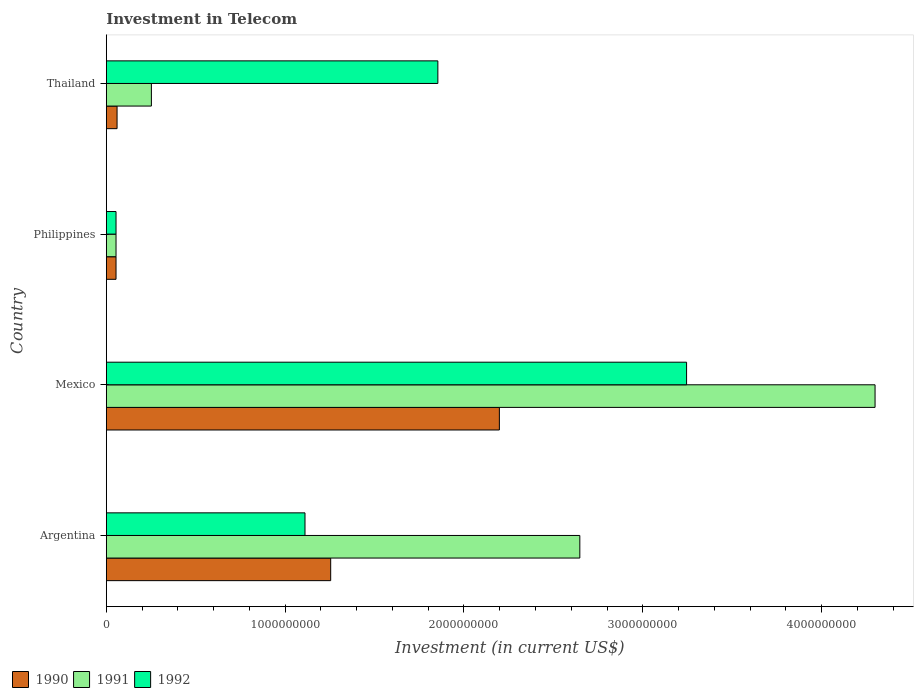How many different coloured bars are there?
Give a very brief answer. 3. How many bars are there on the 3rd tick from the top?
Give a very brief answer. 3. How many bars are there on the 3rd tick from the bottom?
Provide a short and direct response. 3. What is the label of the 1st group of bars from the top?
Your answer should be compact. Thailand. In how many cases, is the number of bars for a given country not equal to the number of legend labels?
Your answer should be very brief. 0. What is the amount invested in telecom in 1990 in Argentina?
Ensure brevity in your answer.  1.25e+09. Across all countries, what is the maximum amount invested in telecom in 1991?
Make the answer very short. 4.30e+09. Across all countries, what is the minimum amount invested in telecom in 1991?
Keep it short and to the point. 5.42e+07. What is the total amount invested in telecom in 1991 in the graph?
Your response must be concise. 7.25e+09. What is the difference between the amount invested in telecom in 1990 in Philippines and that in Thailand?
Provide a succinct answer. -5.80e+06. What is the difference between the amount invested in telecom in 1992 in Argentina and the amount invested in telecom in 1991 in Philippines?
Ensure brevity in your answer.  1.06e+09. What is the average amount invested in telecom in 1991 per country?
Offer a terse response. 1.81e+09. What is the difference between the amount invested in telecom in 1992 and amount invested in telecom in 1991 in Mexico?
Offer a very short reply. -1.05e+09. In how many countries, is the amount invested in telecom in 1991 greater than 200000000 US$?
Your answer should be compact. 3. What is the ratio of the amount invested in telecom in 1992 in Mexico to that in Philippines?
Provide a short and direct response. 59.87. Is the amount invested in telecom in 1990 in Mexico less than that in Philippines?
Provide a succinct answer. No. What is the difference between the highest and the second highest amount invested in telecom in 1992?
Provide a short and direct response. 1.39e+09. What is the difference between the highest and the lowest amount invested in telecom in 1990?
Offer a very short reply. 2.14e+09. Is the sum of the amount invested in telecom in 1991 in Argentina and Mexico greater than the maximum amount invested in telecom in 1990 across all countries?
Offer a very short reply. Yes. Is it the case that in every country, the sum of the amount invested in telecom in 1992 and amount invested in telecom in 1991 is greater than the amount invested in telecom in 1990?
Your response must be concise. Yes. How many bars are there?
Offer a very short reply. 12. Are all the bars in the graph horizontal?
Keep it short and to the point. Yes. Are the values on the major ticks of X-axis written in scientific E-notation?
Offer a very short reply. No. Does the graph contain any zero values?
Give a very brief answer. No. How many legend labels are there?
Provide a short and direct response. 3. How are the legend labels stacked?
Give a very brief answer. Horizontal. What is the title of the graph?
Ensure brevity in your answer.  Investment in Telecom. What is the label or title of the X-axis?
Your answer should be compact. Investment (in current US$). What is the label or title of the Y-axis?
Offer a very short reply. Country. What is the Investment (in current US$) in 1990 in Argentina?
Your answer should be very brief. 1.25e+09. What is the Investment (in current US$) of 1991 in Argentina?
Provide a short and direct response. 2.65e+09. What is the Investment (in current US$) of 1992 in Argentina?
Keep it short and to the point. 1.11e+09. What is the Investment (in current US$) of 1990 in Mexico?
Make the answer very short. 2.20e+09. What is the Investment (in current US$) of 1991 in Mexico?
Give a very brief answer. 4.30e+09. What is the Investment (in current US$) of 1992 in Mexico?
Keep it short and to the point. 3.24e+09. What is the Investment (in current US$) in 1990 in Philippines?
Provide a short and direct response. 5.42e+07. What is the Investment (in current US$) of 1991 in Philippines?
Keep it short and to the point. 5.42e+07. What is the Investment (in current US$) of 1992 in Philippines?
Ensure brevity in your answer.  5.42e+07. What is the Investment (in current US$) in 1990 in Thailand?
Keep it short and to the point. 6.00e+07. What is the Investment (in current US$) in 1991 in Thailand?
Your response must be concise. 2.52e+08. What is the Investment (in current US$) in 1992 in Thailand?
Keep it short and to the point. 1.85e+09. Across all countries, what is the maximum Investment (in current US$) of 1990?
Your response must be concise. 2.20e+09. Across all countries, what is the maximum Investment (in current US$) of 1991?
Your answer should be very brief. 4.30e+09. Across all countries, what is the maximum Investment (in current US$) of 1992?
Make the answer very short. 3.24e+09. Across all countries, what is the minimum Investment (in current US$) in 1990?
Your answer should be compact. 5.42e+07. Across all countries, what is the minimum Investment (in current US$) of 1991?
Keep it short and to the point. 5.42e+07. Across all countries, what is the minimum Investment (in current US$) in 1992?
Offer a very short reply. 5.42e+07. What is the total Investment (in current US$) in 1990 in the graph?
Offer a very short reply. 3.57e+09. What is the total Investment (in current US$) in 1991 in the graph?
Your answer should be compact. 7.25e+09. What is the total Investment (in current US$) of 1992 in the graph?
Offer a very short reply. 6.26e+09. What is the difference between the Investment (in current US$) of 1990 in Argentina and that in Mexico?
Provide a short and direct response. -9.43e+08. What is the difference between the Investment (in current US$) in 1991 in Argentina and that in Mexico?
Keep it short and to the point. -1.65e+09. What is the difference between the Investment (in current US$) in 1992 in Argentina and that in Mexico?
Make the answer very short. -2.13e+09. What is the difference between the Investment (in current US$) of 1990 in Argentina and that in Philippines?
Give a very brief answer. 1.20e+09. What is the difference between the Investment (in current US$) of 1991 in Argentina and that in Philippines?
Your answer should be compact. 2.59e+09. What is the difference between the Investment (in current US$) of 1992 in Argentina and that in Philippines?
Offer a very short reply. 1.06e+09. What is the difference between the Investment (in current US$) in 1990 in Argentina and that in Thailand?
Ensure brevity in your answer.  1.19e+09. What is the difference between the Investment (in current US$) of 1991 in Argentina and that in Thailand?
Keep it short and to the point. 2.40e+09. What is the difference between the Investment (in current US$) in 1992 in Argentina and that in Thailand?
Your response must be concise. -7.43e+08. What is the difference between the Investment (in current US$) in 1990 in Mexico and that in Philippines?
Provide a short and direct response. 2.14e+09. What is the difference between the Investment (in current US$) of 1991 in Mexico and that in Philippines?
Provide a short and direct response. 4.24e+09. What is the difference between the Investment (in current US$) in 1992 in Mexico and that in Philippines?
Offer a very short reply. 3.19e+09. What is the difference between the Investment (in current US$) of 1990 in Mexico and that in Thailand?
Your response must be concise. 2.14e+09. What is the difference between the Investment (in current US$) in 1991 in Mexico and that in Thailand?
Your response must be concise. 4.05e+09. What is the difference between the Investment (in current US$) of 1992 in Mexico and that in Thailand?
Your answer should be very brief. 1.39e+09. What is the difference between the Investment (in current US$) of 1990 in Philippines and that in Thailand?
Your answer should be compact. -5.80e+06. What is the difference between the Investment (in current US$) in 1991 in Philippines and that in Thailand?
Provide a succinct answer. -1.98e+08. What is the difference between the Investment (in current US$) in 1992 in Philippines and that in Thailand?
Keep it short and to the point. -1.80e+09. What is the difference between the Investment (in current US$) of 1990 in Argentina and the Investment (in current US$) of 1991 in Mexico?
Your answer should be very brief. -3.04e+09. What is the difference between the Investment (in current US$) of 1990 in Argentina and the Investment (in current US$) of 1992 in Mexico?
Make the answer very short. -1.99e+09. What is the difference between the Investment (in current US$) in 1991 in Argentina and the Investment (in current US$) in 1992 in Mexico?
Give a very brief answer. -5.97e+08. What is the difference between the Investment (in current US$) in 1990 in Argentina and the Investment (in current US$) in 1991 in Philippines?
Make the answer very short. 1.20e+09. What is the difference between the Investment (in current US$) of 1990 in Argentina and the Investment (in current US$) of 1992 in Philippines?
Provide a short and direct response. 1.20e+09. What is the difference between the Investment (in current US$) of 1991 in Argentina and the Investment (in current US$) of 1992 in Philippines?
Your answer should be compact. 2.59e+09. What is the difference between the Investment (in current US$) of 1990 in Argentina and the Investment (in current US$) of 1991 in Thailand?
Make the answer very short. 1.00e+09. What is the difference between the Investment (in current US$) of 1990 in Argentina and the Investment (in current US$) of 1992 in Thailand?
Provide a succinct answer. -5.99e+08. What is the difference between the Investment (in current US$) of 1991 in Argentina and the Investment (in current US$) of 1992 in Thailand?
Your answer should be compact. 7.94e+08. What is the difference between the Investment (in current US$) of 1990 in Mexico and the Investment (in current US$) of 1991 in Philippines?
Your answer should be compact. 2.14e+09. What is the difference between the Investment (in current US$) of 1990 in Mexico and the Investment (in current US$) of 1992 in Philippines?
Your answer should be compact. 2.14e+09. What is the difference between the Investment (in current US$) in 1991 in Mexico and the Investment (in current US$) in 1992 in Philippines?
Give a very brief answer. 4.24e+09. What is the difference between the Investment (in current US$) in 1990 in Mexico and the Investment (in current US$) in 1991 in Thailand?
Keep it short and to the point. 1.95e+09. What is the difference between the Investment (in current US$) of 1990 in Mexico and the Investment (in current US$) of 1992 in Thailand?
Keep it short and to the point. 3.44e+08. What is the difference between the Investment (in current US$) of 1991 in Mexico and the Investment (in current US$) of 1992 in Thailand?
Make the answer very short. 2.44e+09. What is the difference between the Investment (in current US$) of 1990 in Philippines and the Investment (in current US$) of 1991 in Thailand?
Provide a succinct answer. -1.98e+08. What is the difference between the Investment (in current US$) of 1990 in Philippines and the Investment (in current US$) of 1992 in Thailand?
Provide a short and direct response. -1.80e+09. What is the difference between the Investment (in current US$) in 1991 in Philippines and the Investment (in current US$) in 1992 in Thailand?
Make the answer very short. -1.80e+09. What is the average Investment (in current US$) of 1990 per country?
Ensure brevity in your answer.  8.92e+08. What is the average Investment (in current US$) of 1991 per country?
Keep it short and to the point. 1.81e+09. What is the average Investment (in current US$) in 1992 per country?
Offer a terse response. 1.57e+09. What is the difference between the Investment (in current US$) of 1990 and Investment (in current US$) of 1991 in Argentina?
Keep it short and to the point. -1.39e+09. What is the difference between the Investment (in current US$) in 1990 and Investment (in current US$) in 1992 in Argentina?
Make the answer very short. 1.44e+08. What is the difference between the Investment (in current US$) of 1991 and Investment (in current US$) of 1992 in Argentina?
Provide a succinct answer. 1.54e+09. What is the difference between the Investment (in current US$) of 1990 and Investment (in current US$) of 1991 in Mexico?
Your answer should be very brief. -2.10e+09. What is the difference between the Investment (in current US$) of 1990 and Investment (in current US$) of 1992 in Mexico?
Your answer should be very brief. -1.05e+09. What is the difference between the Investment (in current US$) of 1991 and Investment (in current US$) of 1992 in Mexico?
Your answer should be compact. 1.05e+09. What is the difference between the Investment (in current US$) of 1990 and Investment (in current US$) of 1991 in Philippines?
Offer a terse response. 0. What is the difference between the Investment (in current US$) in 1990 and Investment (in current US$) in 1992 in Philippines?
Keep it short and to the point. 0. What is the difference between the Investment (in current US$) in 1991 and Investment (in current US$) in 1992 in Philippines?
Offer a terse response. 0. What is the difference between the Investment (in current US$) in 1990 and Investment (in current US$) in 1991 in Thailand?
Offer a very short reply. -1.92e+08. What is the difference between the Investment (in current US$) of 1990 and Investment (in current US$) of 1992 in Thailand?
Your answer should be compact. -1.79e+09. What is the difference between the Investment (in current US$) of 1991 and Investment (in current US$) of 1992 in Thailand?
Offer a very short reply. -1.60e+09. What is the ratio of the Investment (in current US$) in 1990 in Argentina to that in Mexico?
Make the answer very short. 0.57. What is the ratio of the Investment (in current US$) of 1991 in Argentina to that in Mexico?
Your answer should be very brief. 0.62. What is the ratio of the Investment (in current US$) in 1992 in Argentina to that in Mexico?
Provide a succinct answer. 0.34. What is the ratio of the Investment (in current US$) of 1990 in Argentina to that in Philippines?
Make the answer very short. 23.15. What is the ratio of the Investment (in current US$) of 1991 in Argentina to that in Philippines?
Provide a short and direct response. 48.86. What is the ratio of the Investment (in current US$) of 1992 in Argentina to that in Philippines?
Make the answer very short. 20.5. What is the ratio of the Investment (in current US$) in 1990 in Argentina to that in Thailand?
Offer a very short reply. 20.91. What is the ratio of the Investment (in current US$) of 1991 in Argentina to that in Thailand?
Offer a terse response. 10.51. What is the ratio of the Investment (in current US$) in 1992 in Argentina to that in Thailand?
Offer a terse response. 0.6. What is the ratio of the Investment (in current US$) of 1990 in Mexico to that in Philippines?
Keep it short and to the point. 40.55. What is the ratio of the Investment (in current US$) in 1991 in Mexico to that in Philippines?
Offer a very short reply. 79.32. What is the ratio of the Investment (in current US$) in 1992 in Mexico to that in Philippines?
Provide a succinct answer. 59.87. What is the ratio of the Investment (in current US$) in 1990 in Mexico to that in Thailand?
Your response must be concise. 36.63. What is the ratio of the Investment (in current US$) in 1991 in Mexico to that in Thailand?
Your answer should be very brief. 17.06. What is the ratio of the Investment (in current US$) of 1992 in Mexico to that in Thailand?
Make the answer very short. 1.75. What is the ratio of the Investment (in current US$) in 1990 in Philippines to that in Thailand?
Keep it short and to the point. 0.9. What is the ratio of the Investment (in current US$) in 1991 in Philippines to that in Thailand?
Your answer should be very brief. 0.22. What is the ratio of the Investment (in current US$) in 1992 in Philippines to that in Thailand?
Your answer should be very brief. 0.03. What is the difference between the highest and the second highest Investment (in current US$) of 1990?
Ensure brevity in your answer.  9.43e+08. What is the difference between the highest and the second highest Investment (in current US$) of 1991?
Your response must be concise. 1.65e+09. What is the difference between the highest and the second highest Investment (in current US$) in 1992?
Make the answer very short. 1.39e+09. What is the difference between the highest and the lowest Investment (in current US$) of 1990?
Make the answer very short. 2.14e+09. What is the difference between the highest and the lowest Investment (in current US$) of 1991?
Offer a very short reply. 4.24e+09. What is the difference between the highest and the lowest Investment (in current US$) in 1992?
Your answer should be very brief. 3.19e+09. 